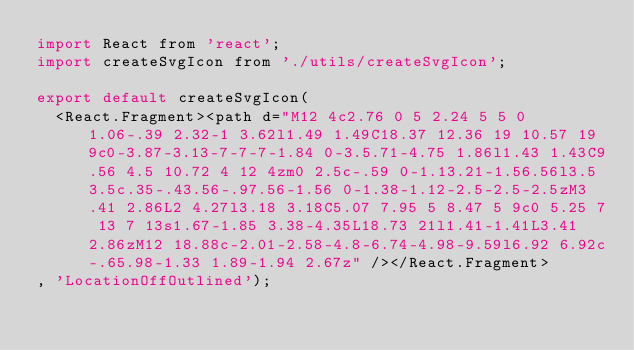<code> <loc_0><loc_0><loc_500><loc_500><_JavaScript_>import React from 'react';
import createSvgIcon from './utils/createSvgIcon';

export default createSvgIcon(
  <React.Fragment><path d="M12 4c2.76 0 5 2.24 5 5 0 1.06-.39 2.32-1 3.62l1.49 1.49C18.37 12.36 19 10.57 19 9c0-3.87-3.13-7-7-7-1.84 0-3.5.71-4.75 1.86l1.43 1.43C9.56 4.5 10.72 4 12 4zm0 2.5c-.59 0-1.13.21-1.56.56l3.5 3.5c.35-.43.56-.97.56-1.56 0-1.38-1.12-2.5-2.5-2.5zM3.41 2.86L2 4.27l3.18 3.18C5.07 7.95 5 8.47 5 9c0 5.25 7 13 7 13s1.67-1.85 3.38-4.35L18.73 21l1.41-1.41L3.41 2.86zM12 18.88c-2.01-2.58-4.8-6.74-4.98-9.59l6.92 6.92c-.65.98-1.33 1.89-1.94 2.67z" /></React.Fragment>
, 'LocationOffOutlined');
</code> 